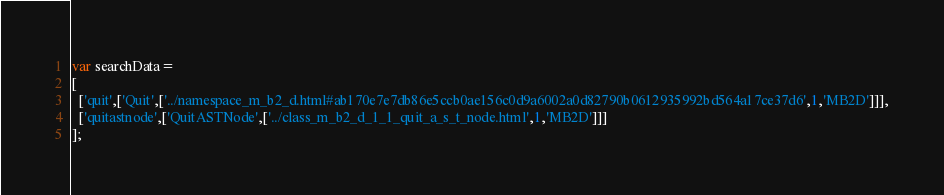<code> <loc_0><loc_0><loc_500><loc_500><_JavaScript_>var searchData=
[
  ['quit',['Quit',['../namespace_m_b2_d.html#ab170e7e7db86e5ccb0ae156c0d9a6002a0d82790b0612935992bd564a17ce37d6',1,'MB2D']]],
  ['quitastnode',['QuitASTNode',['../class_m_b2_d_1_1_quit_a_s_t_node.html',1,'MB2D']]]
];
</code> 